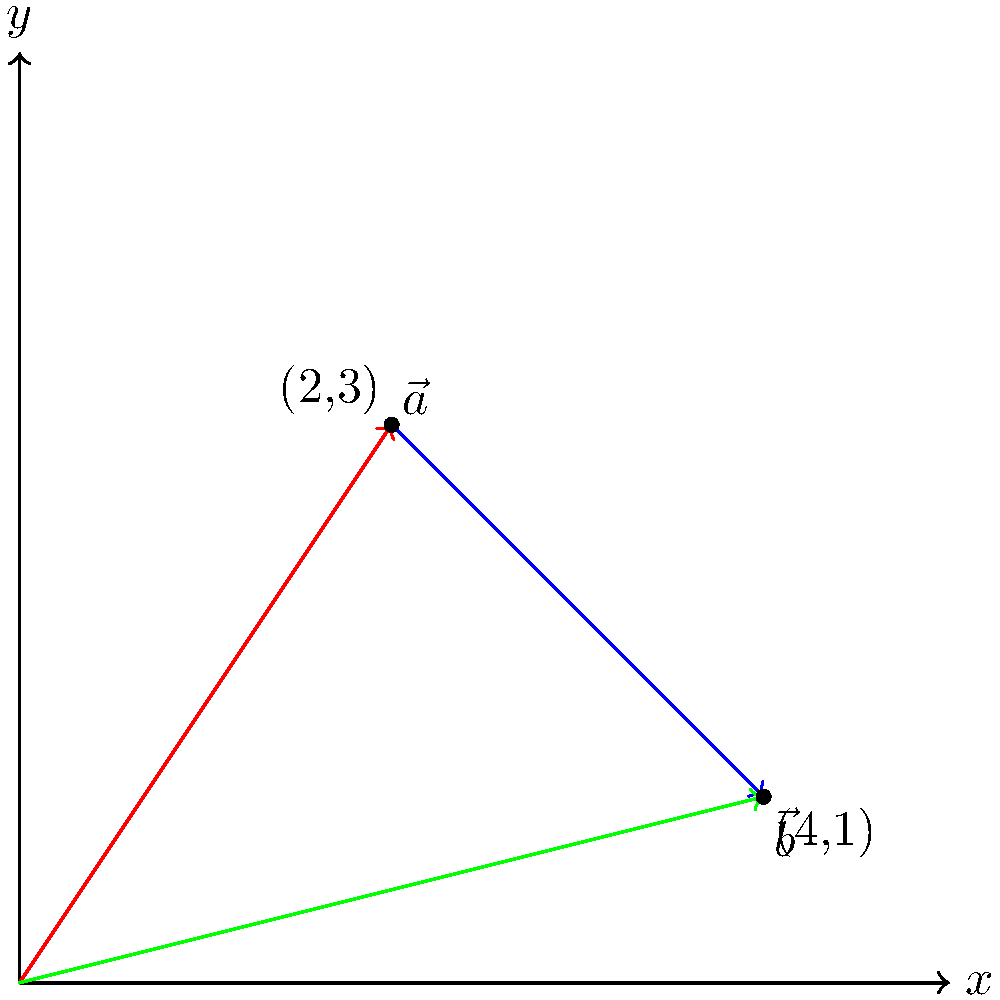Given two vectors $\vec{a} = (2,3)$ and $\vec{b} = (4,1)$ in a 2D plane as shown in the diagram, calculate their dot product. How does this result relate to the angle between the vectors? To calculate the dot product and understand its relation to the angle between vectors, we'll follow these steps:

1) The dot product formula for two vectors $\vec{a} = (a_1, a_2)$ and $\vec{b} = (b_1, b_2)$ is:

   $$\vec{a} \cdot \vec{b} = a_1b_1 + a_2b_2$$

2) Substituting our values:
   
   $$\vec{a} \cdot \vec{b} = (2)(4) + (3)(1) = 8 + 3 = 11$$

3) The dot product is also related to the angle $\theta$ between vectors by:

   $$\vec{a} \cdot \vec{b} = |\vec{a}||\vec{b}|\cos(\theta)$$

4) To find $|\vec{a}|$ and $|\vec{b}|$:
   
   $$|\vec{a}| = \sqrt{2^2 + 3^2} = \sqrt{13}$$
   $$|\vec{b}| = \sqrt{4^2 + 1^2} = \sqrt{17}$$

5) Now we can solve for $\cos(\theta)$:

   $$11 = \sqrt{13}\sqrt{17}\cos(\theta)$$
   $$\cos(\theta) = \frac{11}{\sqrt{221}} \approx 0.7398$$

6) Taking the inverse cosine:

   $$\theta = \arccos(0.7398) \approx 0.7373 \text{ radians} \approx 42.24^\circ$$

This demonstrates that the dot product is positive when the angle between vectors is acute (less than 90°), which aligns with our visual inspection of the diagram.
Answer: 11; acute angle of approximately 42.24° 